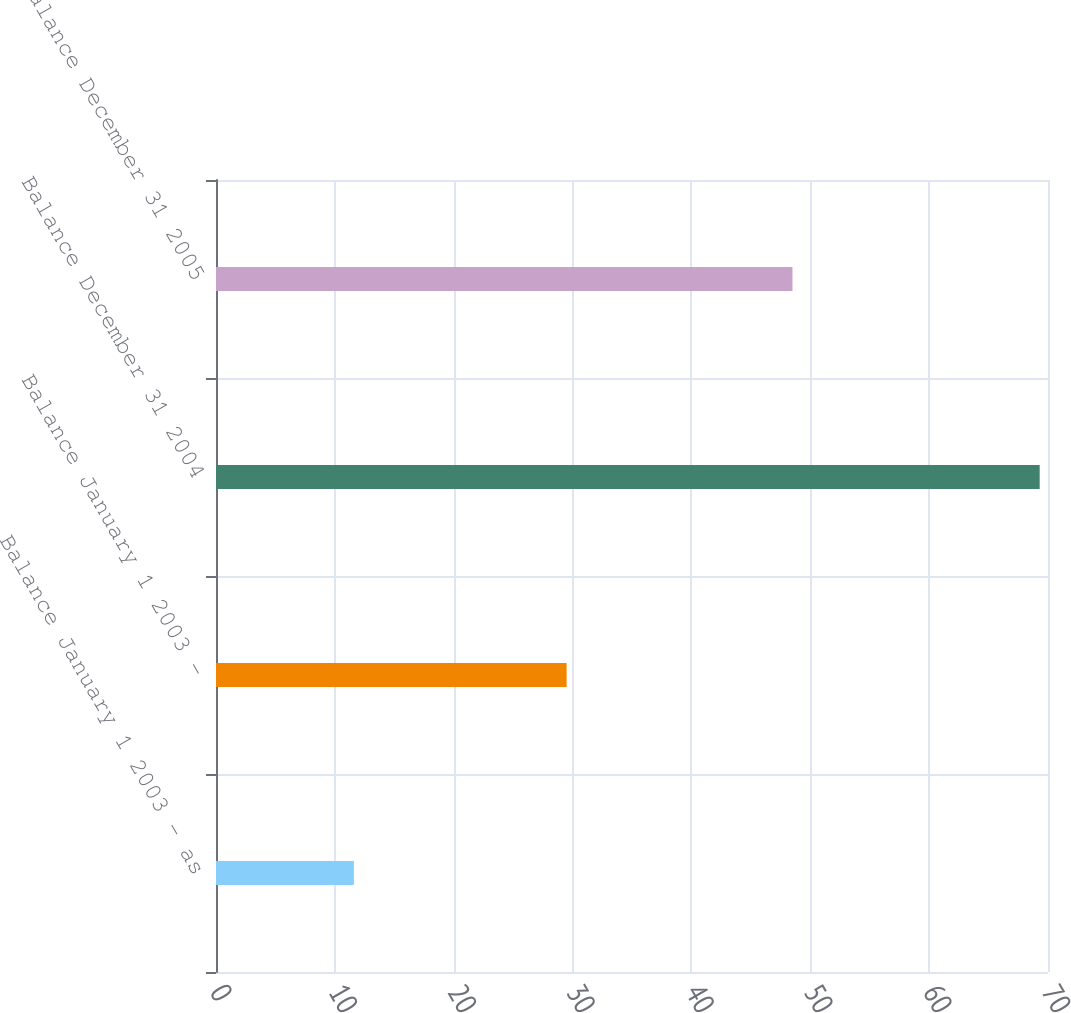<chart> <loc_0><loc_0><loc_500><loc_500><bar_chart><fcel>Balance January 1 2003 - as<fcel>Balance January 1 2003 -<fcel>Balance December 31 2004<fcel>Balance December 31 2005<nl><fcel>11.6<fcel>29.5<fcel>69.3<fcel>48.5<nl></chart> 